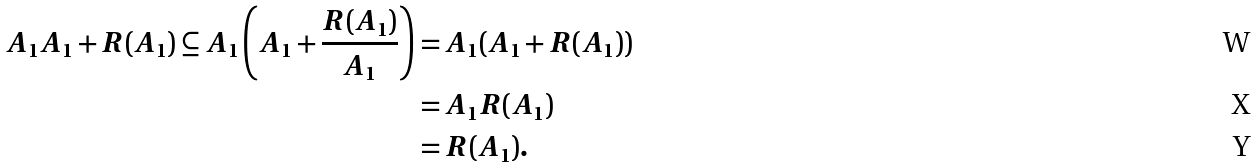<formula> <loc_0><loc_0><loc_500><loc_500>A _ { 1 } A _ { 1 } + R ( A _ { 1 } ) \subseteq A _ { 1 } \left ( A _ { 1 } + \frac { R ( A _ { 1 } ) } { A _ { 1 } } \right ) & = A _ { 1 } ( A _ { 1 } + R ( A _ { 1 } ) ) \\ & = A _ { 1 } R ( A _ { 1 } ) \\ & = R ( A _ { 1 } ) .</formula> 